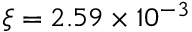Convert formula to latex. <formula><loc_0><loc_0><loc_500><loc_500>\xi = 2 . 5 9 \times 1 0 ^ { - 3 }</formula> 